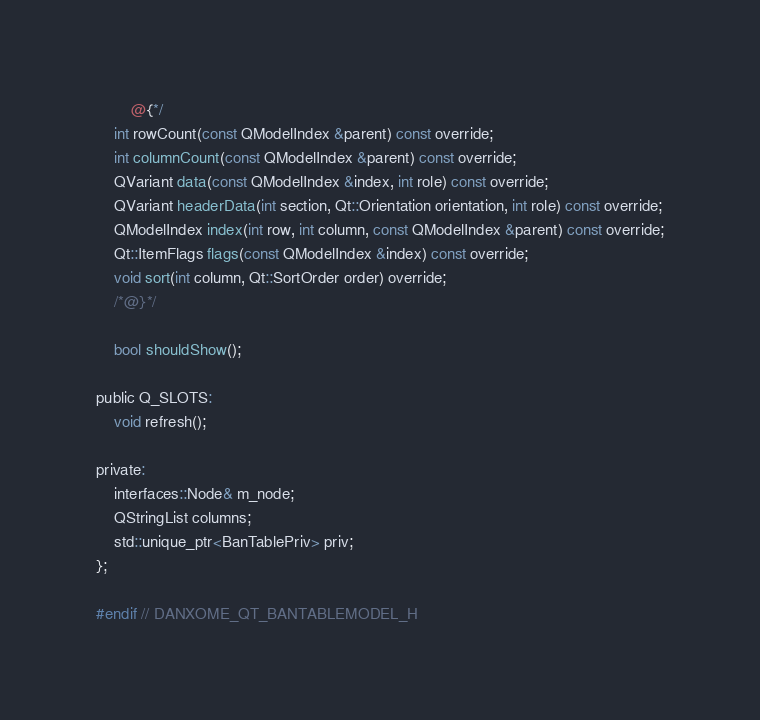<code> <loc_0><loc_0><loc_500><loc_500><_C_>        @{*/
    int rowCount(const QModelIndex &parent) const override;
    int columnCount(const QModelIndex &parent) const override;
    QVariant data(const QModelIndex &index, int role) const override;
    QVariant headerData(int section, Qt::Orientation orientation, int role) const override;
    QModelIndex index(int row, int column, const QModelIndex &parent) const override;
    Qt::ItemFlags flags(const QModelIndex &index) const override;
    void sort(int column, Qt::SortOrder order) override;
    /*@}*/

    bool shouldShow();

public Q_SLOTS:
    void refresh();

private:
    interfaces::Node& m_node;
    QStringList columns;
    std::unique_ptr<BanTablePriv> priv;
};

#endif // DANXOME_QT_BANTABLEMODEL_H
</code> 